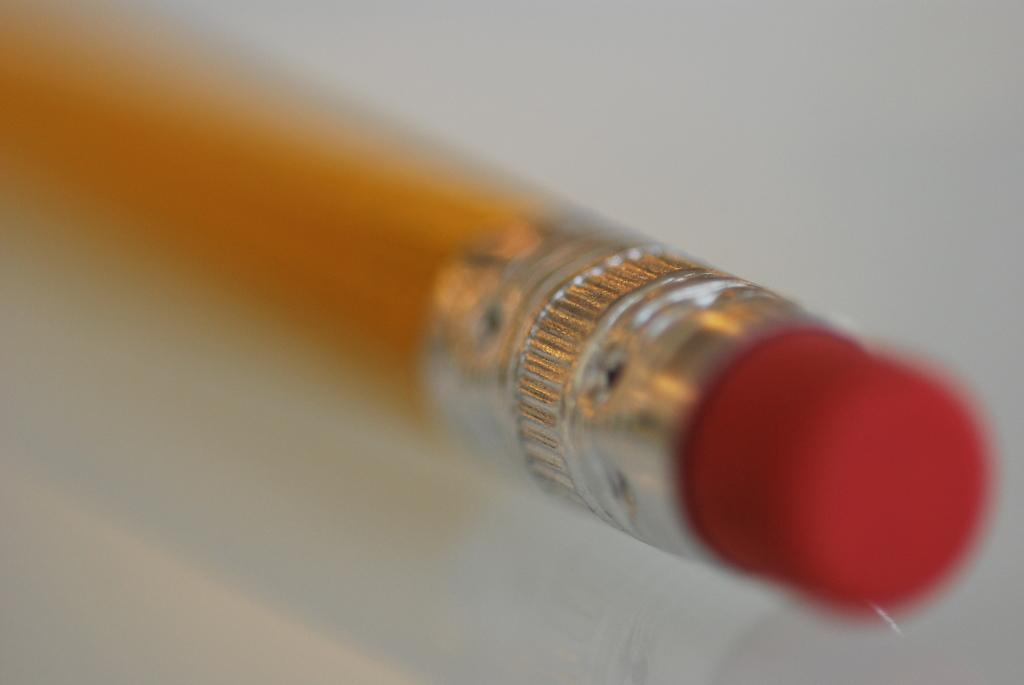What can be seen in the image? There is an object in the image. How many ducks are present in the image? There are no ducks present in the image; only an object is mentioned. What is the object's desire in the image? The object does not have desires, as it is an inanimate object. 